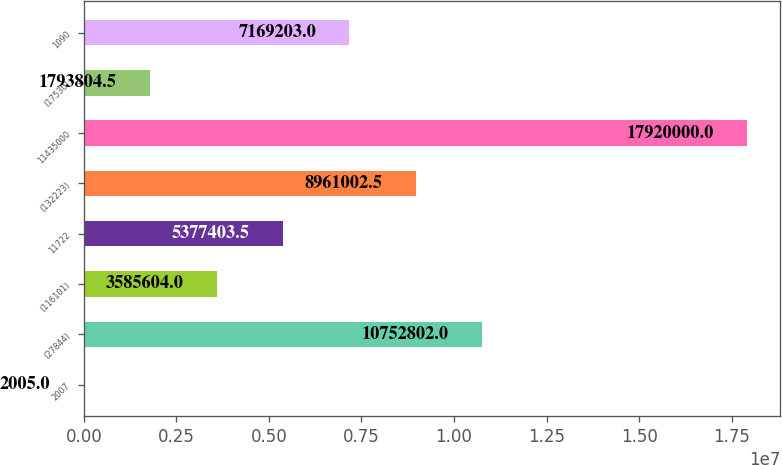Convert chart to OTSL. <chart><loc_0><loc_0><loc_500><loc_500><bar_chart><fcel>2007<fcel>(27844)<fcel>(116101)<fcel>11722<fcel>(132223)<fcel>11435000<fcel>(17530)<fcel>1090<nl><fcel>2005<fcel>1.07528e+07<fcel>3.5856e+06<fcel>5.3774e+06<fcel>8.961e+06<fcel>1.792e+07<fcel>1.7938e+06<fcel>7.1692e+06<nl></chart> 